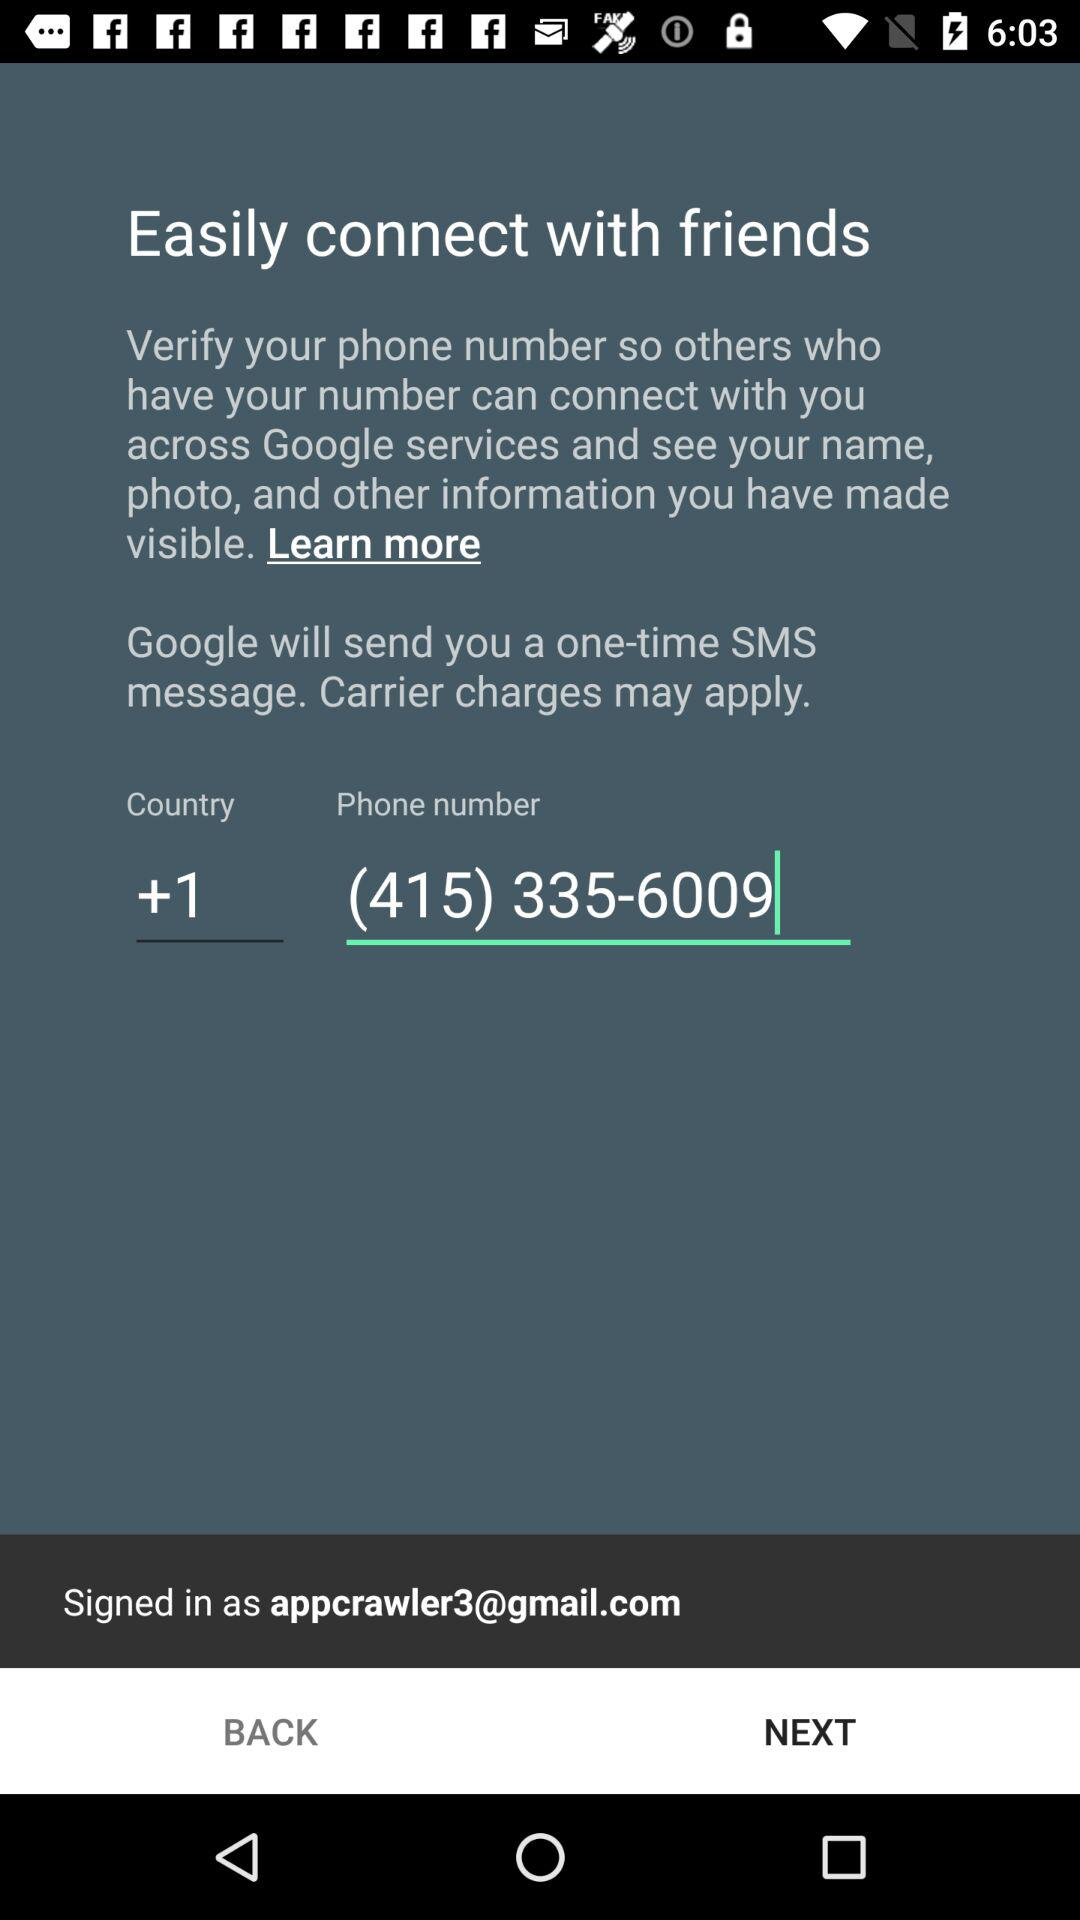What is the email address? The email address is appcrawler3@gmail.com. 